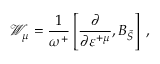<formula> <loc_0><loc_0><loc_500><loc_500>\mathcal { W } _ { \mu } = \frac { 1 } \omega ^ { + } } \left [ \frac { \partial } \partial \varepsilon ^ { + \mu } } , B _ { \widetilde { S } } \right ] \, ,</formula> 